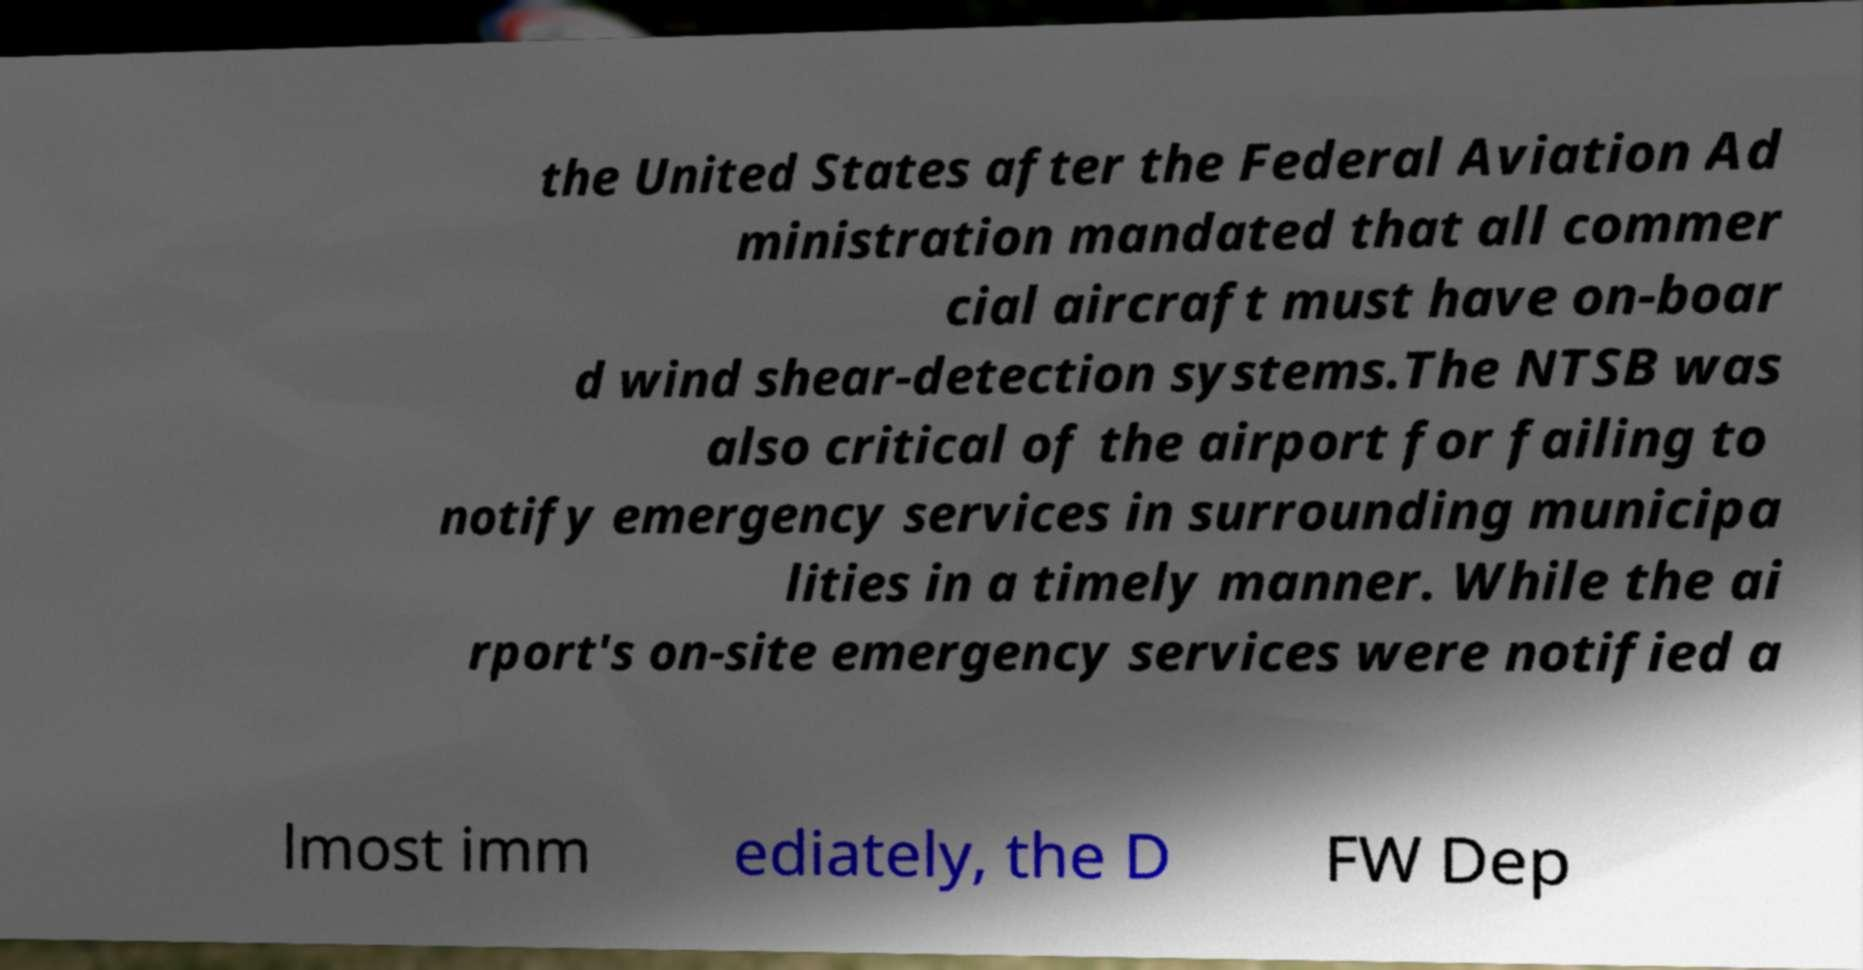Can you accurately transcribe the text from the provided image for me? the United States after the Federal Aviation Ad ministration mandated that all commer cial aircraft must have on-boar d wind shear-detection systems.The NTSB was also critical of the airport for failing to notify emergency services in surrounding municipa lities in a timely manner. While the ai rport's on-site emergency services were notified a lmost imm ediately, the D FW Dep 